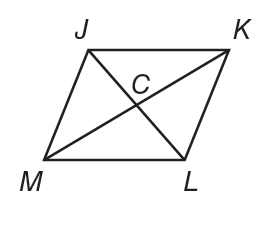Question: J K L M is a rhombus. If C K = 8 and J K = 10. Find J C.
Choices:
A. 4
B. 6
C. 8
D. 10
Answer with the letter. Answer: B 